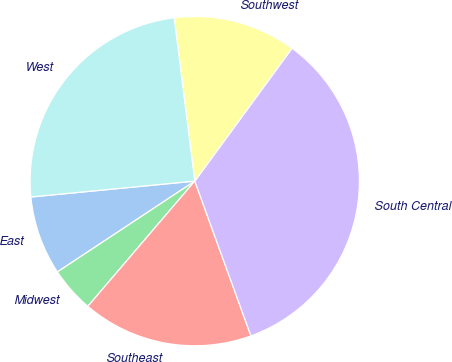<chart> <loc_0><loc_0><loc_500><loc_500><pie_chart><fcel>East<fcel>Midwest<fcel>Southeast<fcel>South Central<fcel>Southwest<fcel>West<nl><fcel>7.76%<fcel>4.45%<fcel>16.79%<fcel>34.4%<fcel>12.05%<fcel>24.54%<nl></chart> 